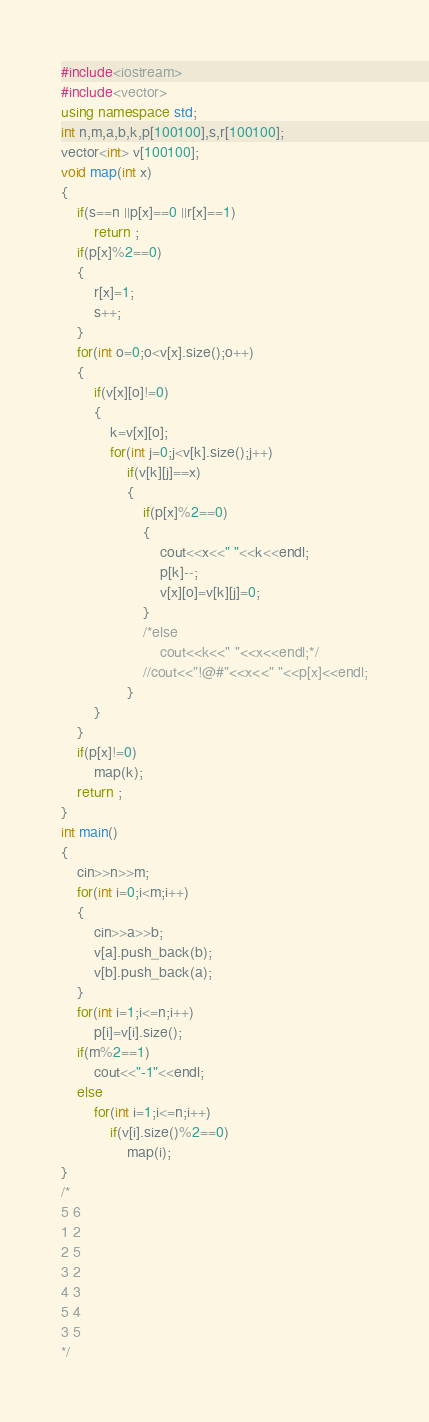<code> <loc_0><loc_0><loc_500><loc_500><_C++_>#include<iostream>
#include<vector>
using namespace std;
int n,m,a,b,k,p[100100],s,r[100100];
vector<int> v[100100];
void map(int x)
{
	if(s==n ||p[x]==0 ||r[x]==1)
		return ;
	if(p[x]%2==0)	
	{
		r[x]=1;	
		s++;
	}
	for(int o=0;o<v[x].size();o++)
	{
		if(v[x][o]!=0)
		{
			k=v[x][o];
			for(int j=0;j<v[k].size();j++)
				if(v[k][j]==x)
				{
					if(p[x]%2==0)
					{
						cout<<x<<" "<<k<<endl;
						p[k]--;
						v[x][o]=v[k][j]=0;
					}
					/*else
						cout<<k<<" "<<x<<endl;*/	
					//cout<<"!@#"<<x<<" "<<p[x]<<endl;
				}	
		}
	}
	if(p[x]!=0)
		map(k);	
	return ;
}
int main()
{
	cin>>n>>m;
	for(int i=0;i<m;i++)
	{
		cin>>a>>b;
		v[a].push_back(b);
		v[b].push_back(a);
	}
	for(int i=1;i<=n;i++)
		p[i]=v[i].size();
	if(m%2==1)
		cout<<"-1"<<endl;
	else
		for(int i=1;i<=n;i++)
			if(v[i].size()%2==0)
				map(i);
}
/*
5 6
1 2
2 5
3 2
4 3
5 4
3 5
*/</code> 